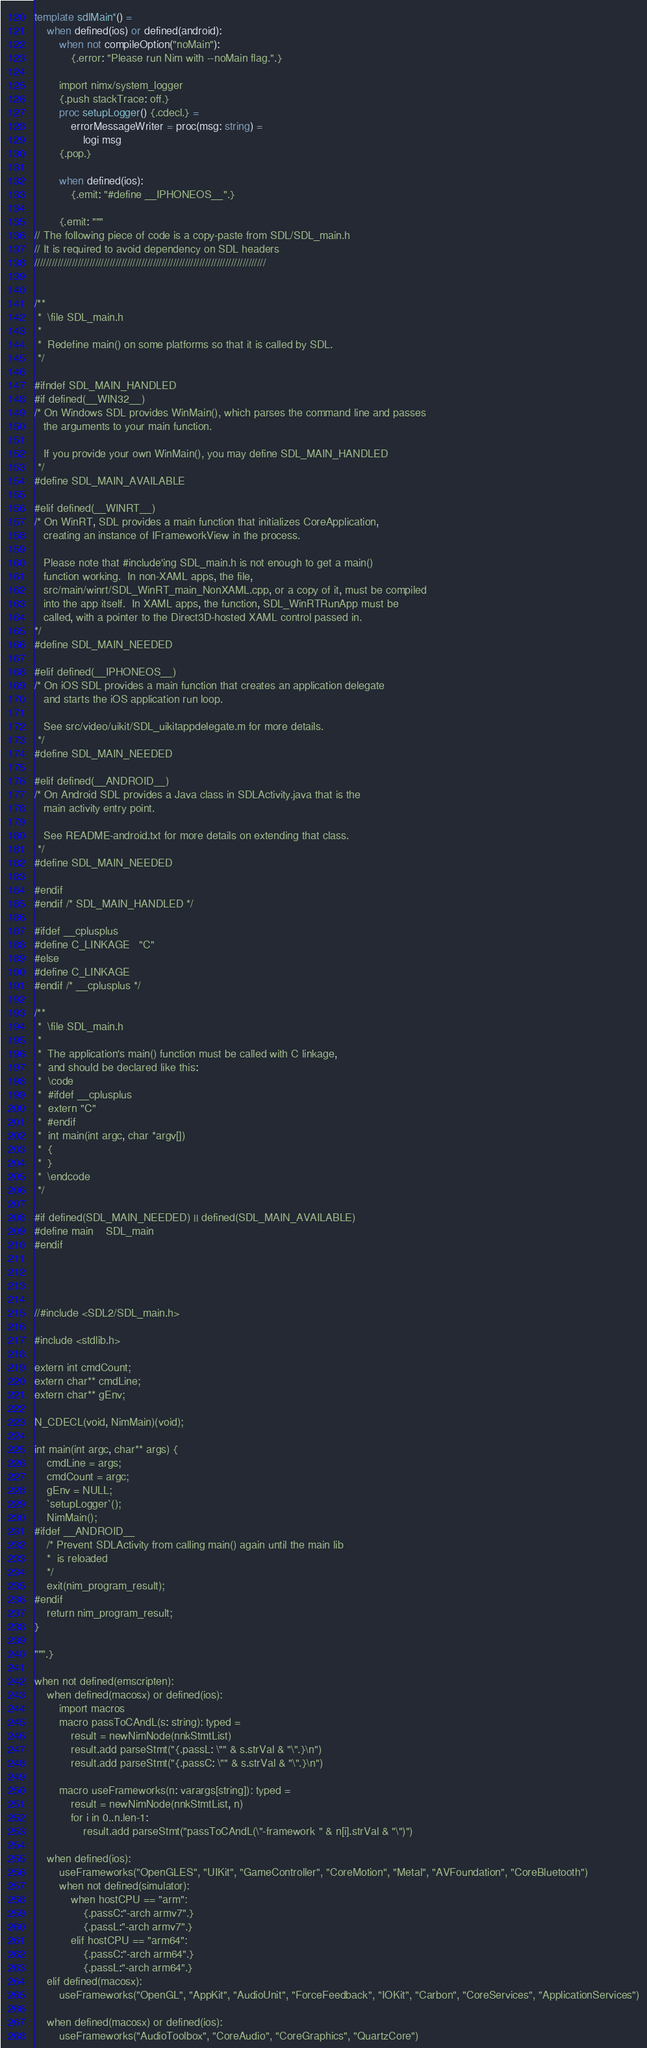Convert code to text. <code><loc_0><loc_0><loc_500><loc_500><_Nim_>
template sdlMain*() =
    when defined(ios) or defined(android):
        when not compileOption("noMain"):
            {.error: "Please run Nim with --noMain flag.".}

        import nimx/system_logger
        {.push stackTrace: off.}
        proc setupLogger() {.cdecl.} =
            errorMessageWriter = proc(msg: string) =
                logi msg
        {.pop.}

        when defined(ios):
            {.emit: "#define __IPHONEOS__".}

        {.emit: """
// The following piece of code is a copy-paste from SDL/SDL_main.h
// It is required to avoid dependency on SDL headers
////////////////////////////////////////////////////////////////////////////////


/**
 *  \file SDL_main.h
 *
 *  Redefine main() on some platforms so that it is called by SDL.
 */

#ifndef SDL_MAIN_HANDLED
#if defined(__WIN32__)
/* On Windows SDL provides WinMain(), which parses the command line and passes
   the arguments to your main function.

   If you provide your own WinMain(), you may define SDL_MAIN_HANDLED
 */
#define SDL_MAIN_AVAILABLE

#elif defined(__WINRT__)
/* On WinRT, SDL provides a main function that initializes CoreApplication,
   creating an instance of IFrameworkView in the process.

   Please note that #include'ing SDL_main.h is not enough to get a main()
   function working.  In non-XAML apps, the file,
   src/main/winrt/SDL_WinRT_main_NonXAML.cpp, or a copy of it, must be compiled
   into the app itself.  In XAML apps, the function, SDL_WinRTRunApp must be
   called, with a pointer to the Direct3D-hosted XAML control passed in.
*/
#define SDL_MAIN_NEEDED

#elif defined(__IPHONEOS__)
/* On iOS SDL provides a main function that creates an application delegate
   and starts the iOS application run loop.

   See src/video/uikit/SDL_uikitappdelegate.m for more details.
 */
#define SDL_MAIN_NEEDED

#elif defined(__ANDROID__)
/* On Android SDL provides a Java class in SDLActivity.java that is the
   main activity entry point.

   See README-android.txt for more details on extending that class.
 */
#define SDL_MAIN_NEEDED

#endif
#endif /* SDL_MAIN_HANDLED */

#ifdef __cplusplus
#define C_LINKAGE   "C"
#else
#define C_LINKAGE
#endif /* __cplusplus */

/**
 *  \file SDL_main.h
 *
 *  The application's main() function must be called with C linkage,
 *  and should be declared like this:
 *  \code
 *  #ifdef __cplusplus
 *  extern "C"
 *  #endif
 *  int main(int argc, char *argv[])
 *  {
 *  }
 *  \endcode
 */

#if defined(SDL_MAIN_NEEDED) || defined(SDL_MAIN_AVAILABLE)
#define main    SDL_main
#endif




//#include <SDL2/SDL_main.h>

#include <stdlib.h>

extern int cmdCount;
extern char** cmdLine;
extern char** gEnv;

N_CDECL(void, NimMain)(void);

int main(int argc, char** args) {
    cmdLine = args;
    cmdCount = argc;
    gEnv = NULL;
    `setupLogger`();
    NimMain();
#ifdef __ANDROID__
    /* Prevent SDLActivity from calling main() again until the main lib
    *  is reloaded
    */
    exit(nim_program_result);
#endif
    return nim_program_result;
}

""".}

when not defined(emscripten):
    when defined(macosx) or defined(ios):
        import macros
        macro passToCAndL(s: string): typed =
            result = newNimNode(nnkStmtList)
            result.add parseStmt("{.passL: \"" & s.strVal & "\".}\n")
            result.add parseStmt("{.passC: \"" & s.strVal & "\".}\n")

        macro useFrameworks(n: varargs[string]): typed =
            result = newNimNode(nnkStmtList, n)
            for i in 0..n.len-1:
                result.add parseStmt("passToCAndL(\"-framework " & n[i].strVal & "\")")

    when defined(ios):
        useFrameworks("OpenGLES", "UIKit", "GameController", "CoreMotion", "Metal", "AVFoundation", "CoreBluetooth")
        when not defined(simulator):
            when hostCPU == "arm":
                {.passC:"-arch armv7".}
                {.passL:"-arch armv7".}
            elif hostCPU == "arm64":
                {.passC:"-arch arm64".}
                {.passL:"-arch arm64".}
    elif defined(macosx):
        useFrameworks("OpenGL", "AppKit", "AudioUnit", "ForceFeedback", "IOKit", "Carbon", "CoreServices", "ApplicationServices")

    when defined(macosx) or defined(ios):
        useFrameworks("AudioToolbox", "CoreAudio", "CoreGraphics", "QuartzCore")
</code> 